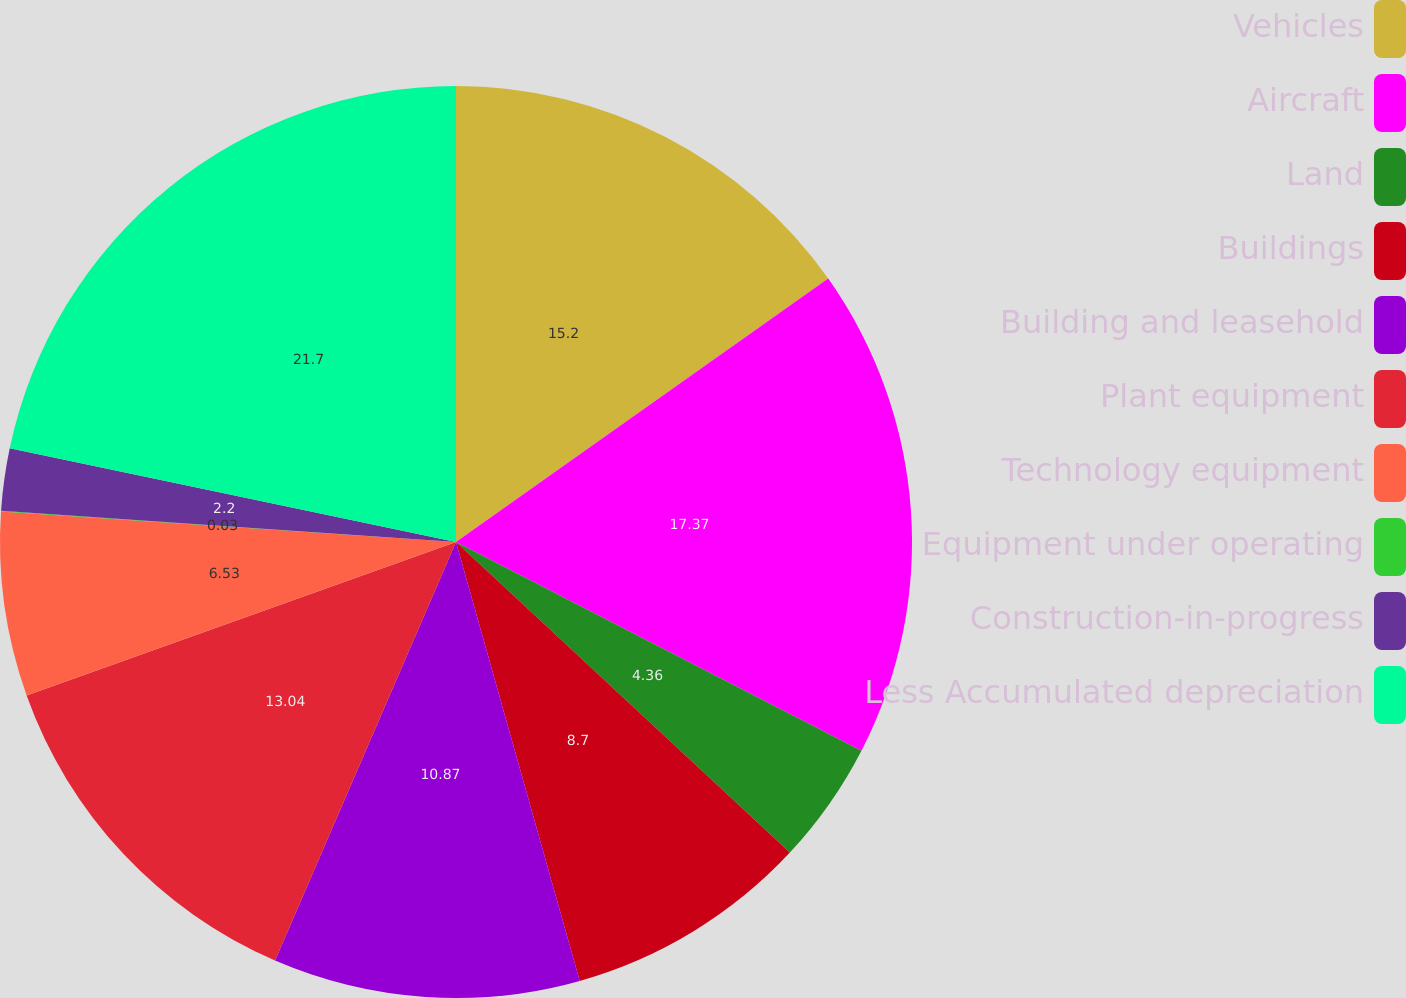<chart> <loc_0><loc_0><loc_500><loc_500><pie_chart><fcel>Vehicles<fcel>Aircraft<fcel>Land<fcel>Buildings<fcel>Building and leasehold<fcel>Plant equipment<fcel>Technology equipment<fcel>Equipment under operating<fcel>Construction-in-progress<fcel>Less Accumulated depreciation<nl><fcel>15.2%<fcel>17.37%<fcel>4.36%<fcel>8.7%<fcel>10.87%<fcel>13.04%<fcel>6.53%<fcel>0.03%<fcel>2.2%<fcel>21.71%<nl></chart> 